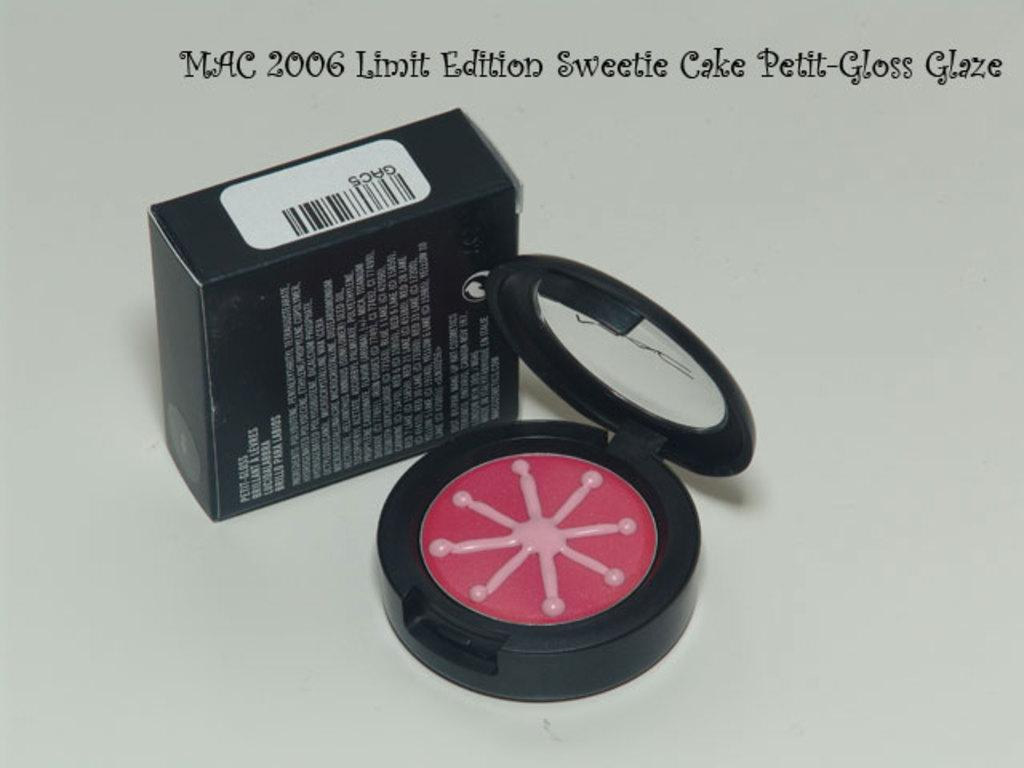<image>
Relay a brief, clear account of the picture shown. Some makeup is next to a box and it says above them Mac 2006 Limit Edition Sweetie Cake Petite-Gloss Glaze. 